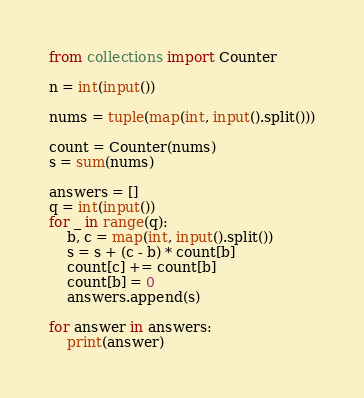Convert code to text. <code><loc_0><loc_0><loc_500><loc_500><_Python_>from collections import Counter

n = int(input())

nums = tuple(map(int, input().split()))

count = Counter(nums)
s = sum(nums)

answers = []
q = int(input())
for _ in range(q):
    b, c = map(int, input().split())
    s = s + (c - b) * count[b]
    count[c] += count[b]
    count[b] = 0
    answers.append(s)
    
for answer in answers:
    print(answer)</code> 